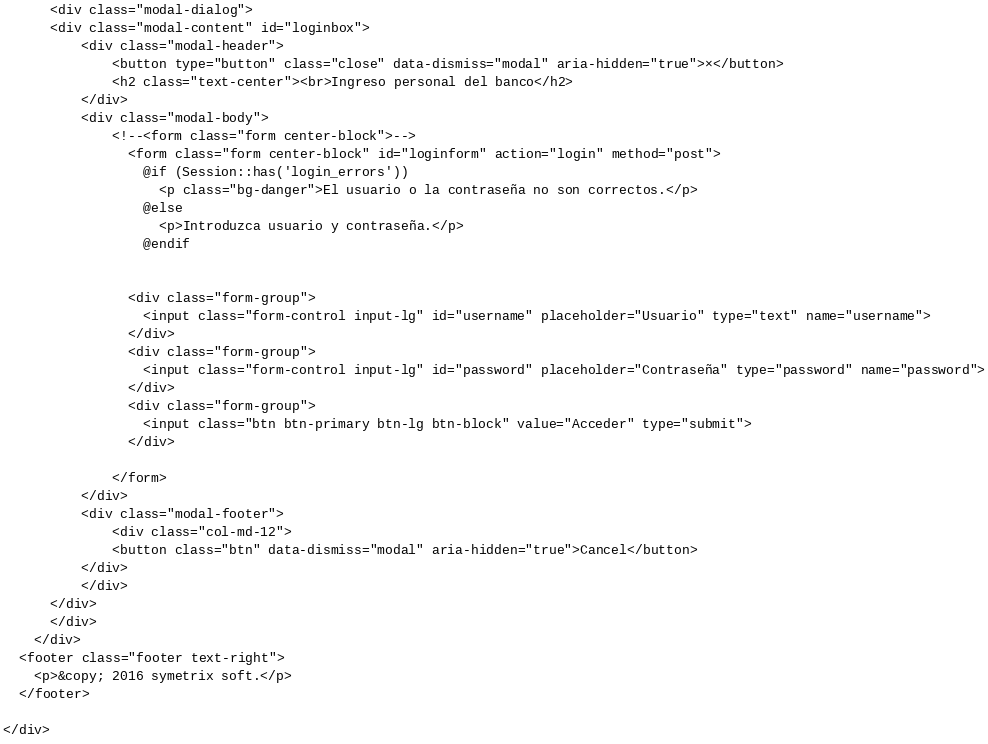<code> <loc_0><loc_0><loc_500><loc_500><_PHP_>      <div class="modal-dialog">
      <div class="modal-content" id="loginbox">
          <div class="modal-header">
              <button type="button" class="close" data-dismiss="modal" aria-hidden="true">×</button>
              <h2 class="text-center"><br>Ingreso personal del banco</h2>
          </div>
          <div class="modal-body">
              <!--<form class="form center-block">-->
                <form class="form center-block" id="loginform" action="login" method="post">
                  @if (Session::has('login_errors'))
                    <p class="bg-danger">El usuario o la contraseña no son correctos.</p>             
                  @else
                    <p>Introduzca usuario y contraseña.</p>
                  @endif


                <div class="form-group">
                  <input class="form-control input-lg" id="username" placeholder="Usuario" type="text" name="username">
                </div>
                <div class="form-group">
                  <input class="form-control input-lg" id="password" placeholder="Contraseña" type="password" name="password">
                </div>
                <div class="form-group">
                  <input class="btn btn-primary btn-lg btn-block" value="Acceder" type="submit">              
                </div>
                
              </form>
          </div>
          <div class="modal-footer">
              <div class="col-md-12">
              <button class="btn" data-dismiss="modal" aria-hidden="true">Cancel</button>
          </div>  
          </div>
      </div>
      </div>
    </div>
  <footer class="footer text-right">
    <p>&copy; 2016 symetrix soft.</p>
  </footer>

</div></code> 